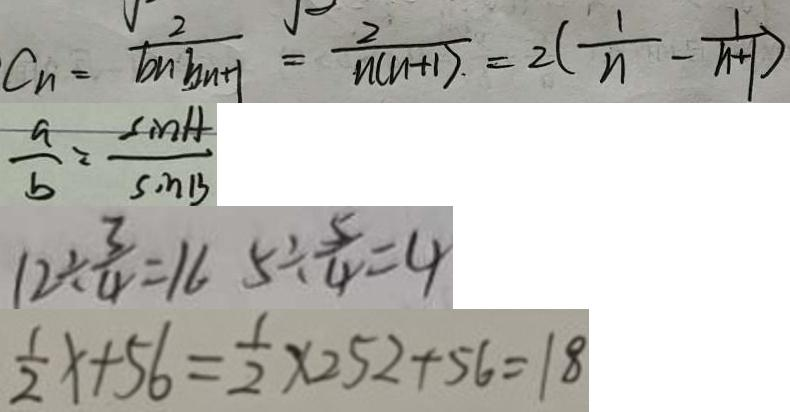Convert formula to latex. <formula><loc_0><loc_0><loc_500><loc_500>C _ { n } = \frac { 2 } { b n \cdot b n + 1 } = \frac { 2 } { n ( n + 1 ) } = 2 ( \frac { 1 } { n } - \frac { 1 } { n + 1 } ) 
 \frac { a } { b } = \frac { \sin A } { \sin B } 
 1 2 \div \frac { 3 } { 4 } = 1 6 5 \div \frac { 5 } { 4 } = 4 
 \frac { 1 } { 2 } x + 5 6 = \frac { 1 } { 2 } \times 2 5 2 + 5 6 = 1 8</formula> 